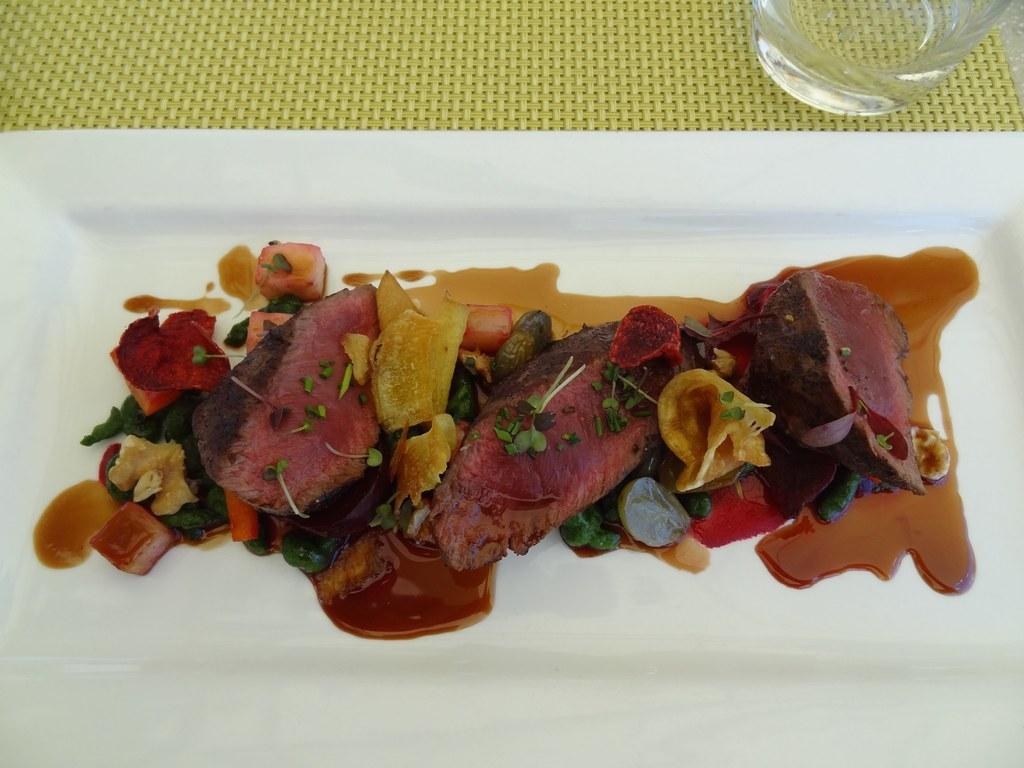What types of food items can be seen in the image? There are food items in the image, including soup in a plate. Can you describe the plate in the image? The plate is on a platform, and it contains soup. What other object is on the platform in the image? There is a glass on the platform in the image. What type of anger can be seen on the cattle's face in the image? There are no cattle present in the image, and therefore no anger can be observed on their faces. 